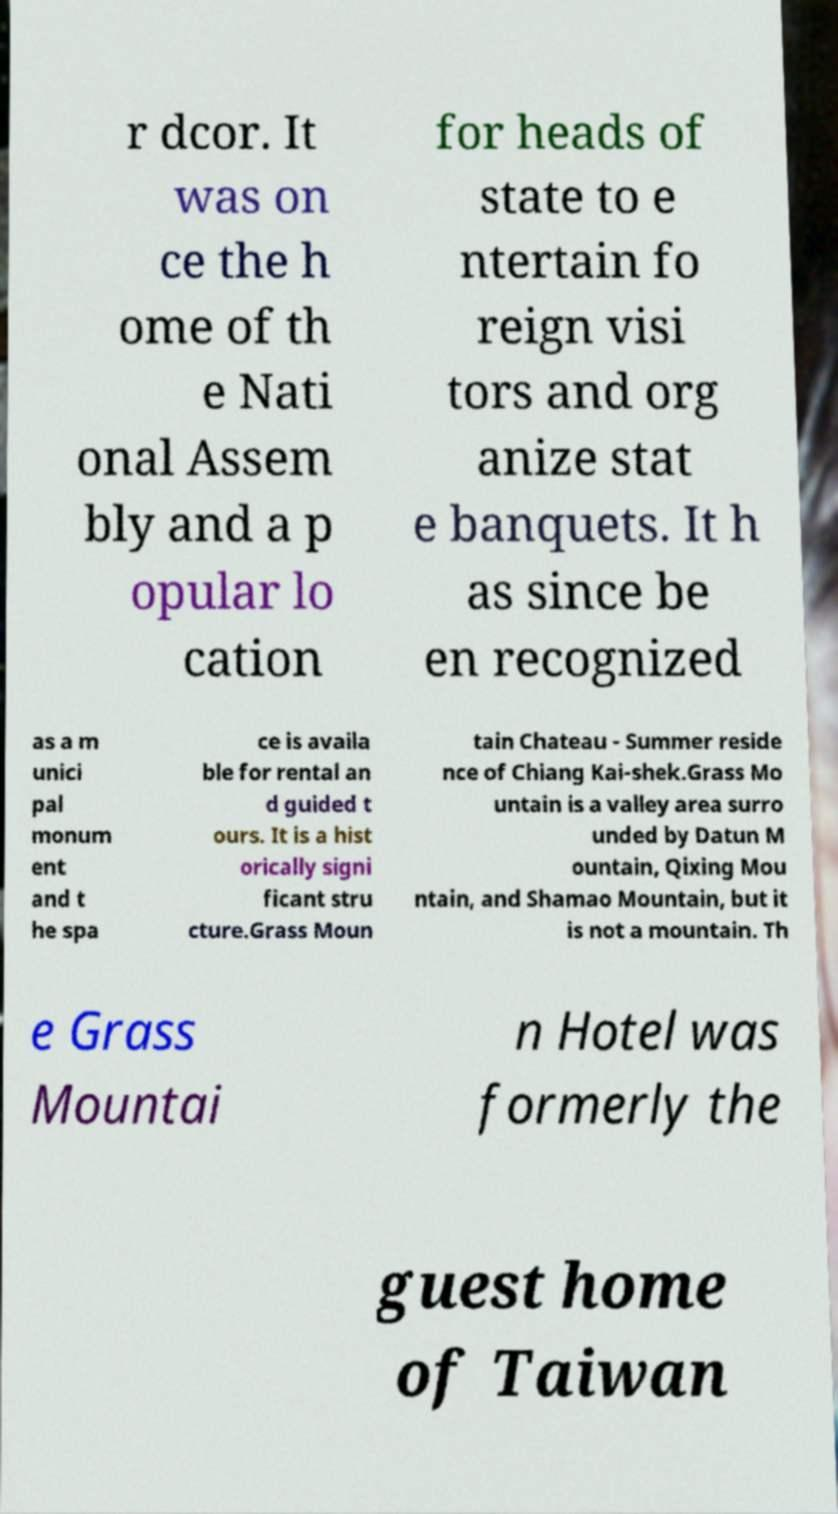Could you extract and type out the text from this image? r dcor. It was on ce the h ome of th e Nati onal Assem bly and a p opular lo cation for heads of state to e ntertain fo reign visi tors and org anize stat e banquets. It h as since be en recognized as a m unici pal monum ent and t he spa ce is availa ble for rental an d guided t ours. It is a hist orically signi ficant stru cture.Grass Moun tain Chateau - Summer reside nce of Chiang Kai-shek.Grass Mo untain is a valley area surro unded by Datun M ountain, Qixing Mou ntain, and Shamao Mountain, but it is not a mountain. Th e Grass Mountai n Hotel was formerly the guest home of Taiwan 